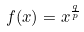<formula> <loc_0><loc_0><loc_500><loc_500>f ( x ) = x ^ { \frac { q } { p } }</formula> 